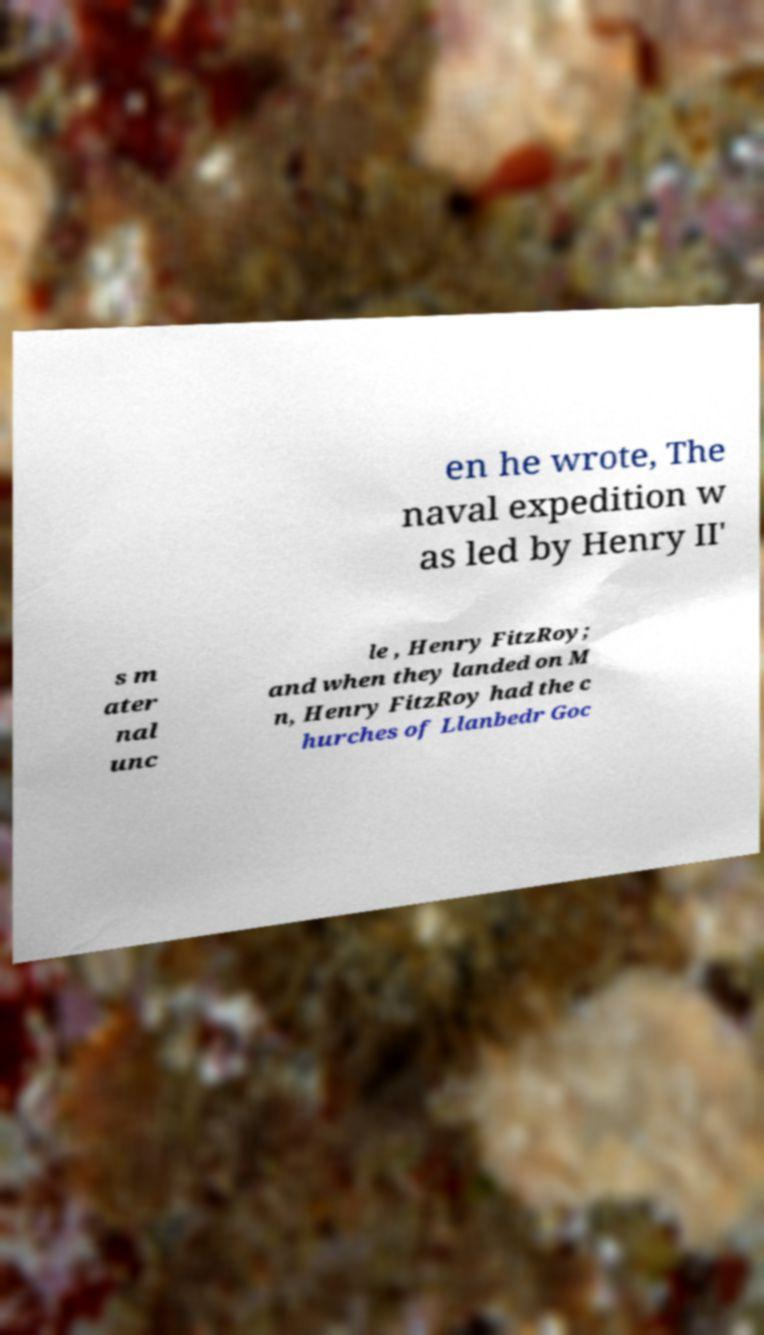There's text embedded in this image that I need extracted. Can you transcribe it verbatim? en he wrote, The naval expedition w as led by Henry II' s m ater nal unc le , Henry FitzRoy; and when they landed on M n, Henry FitzRoy had the c hurches of Llanbedr Goc 